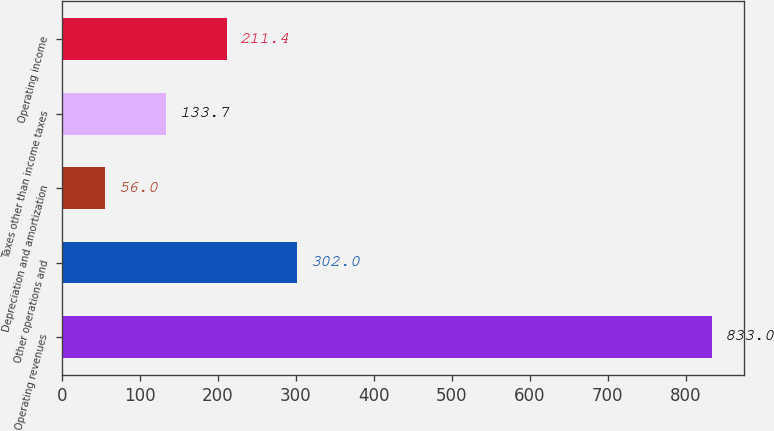Convert chart to OTSL. <chart><loc_0><loc_0><loc_500><loc_500><bar_chart><fcel>Operating revenues<fcel>Other operations and<fcel>Depreciation and amortization<fcel>Taxes other than income taxes<fcel>Operating income<nl><fcel>833<fcel>302<fcel>56<fcel>133.7<fcel>211.4<nl></chart> 